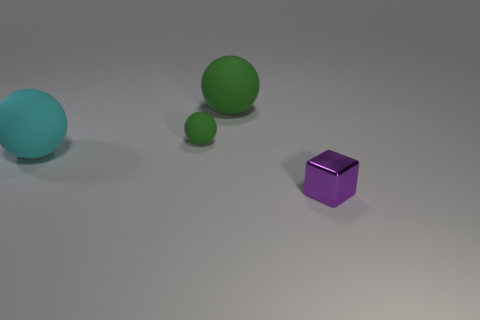Subtract all large cyan rubber balls. How many balls are left? 2 Subtract all yellow blocks. How many green balls are left? 2 Add 4 small red things. How many objects exist? 8 Subtract all cyan balls. How many balls are left? 2 Subtract all balls. How many objects are left? 1 Subtract 1 blocks. How many blocks are left? 0 Add 4 green matte spheres. How many green matte spheres are left? 6 Add 3 cyan cylinders. How many cyan cylinders exist? 3 Subtract 0 yellow blocks. How many objects are left? 4 Subtract all green blocks. Subtract all green balls. How many blocks are left? 1 